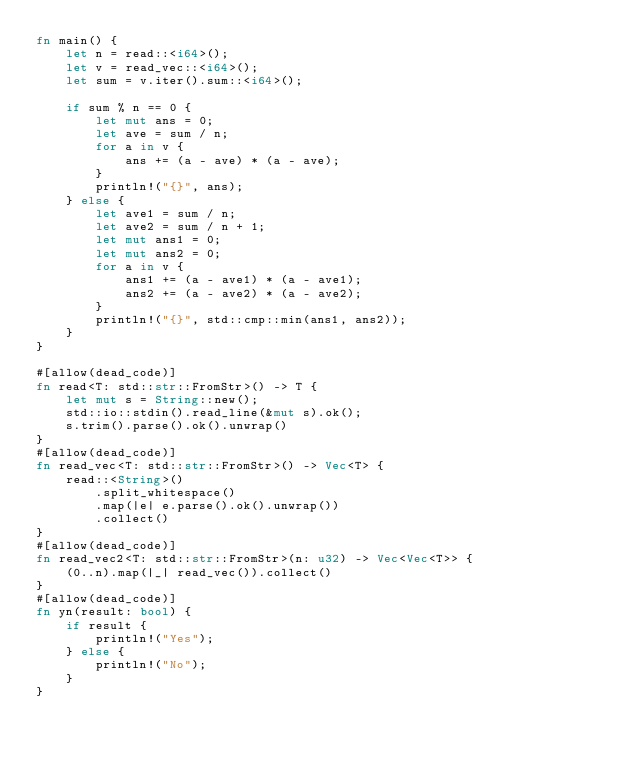<code> <loc_0><loc_0><loc_500><loc_500><_Rust_>fn main() {
    let n = read::<i64>();
    let v = read_vec::<i64>();
    let sum = v.iter().sum::<i64>();

    if sum % n == 0 {
        let mut ans = 0;
        let ave = sum / n;
        for a in v {
            ans += (a - ave) * (a - ave);
        }
        println!("{}", ans);
    } else {
        let ave1 = sum / n;
        let ave2 = sum / n + 1;
        let mut ans1 = 0;
        let mut ans2 = 0;
        for a in v {
            ans1 += (a - ave1) * (a - ave1);
            ans2 += (a - ave2) * (a - ave2);
        }
        println!("{}", std::cmp::min(ans1, ans2));
    }
}

#[allow(dead_code)]
fn read<T: std::str::FromStr>() -> T {
    let mut s = String::new();
    std::io::stdin().read_line(&mut s).ok();
    s.trim().parse().ok().unwrap()
}
#[allow(dead_code)]
fn read_vec<T: std::str::FromStr>() -> Vec<T> {
    read::<String>()
        .split_whitespace()
        .map(|e| e.parse().ok().unwrap())
        .collect()
}
#[allow(dead_code)]
fn read_vec2<T: std::str::FromStr>(n: u32) -> Vec<Vec<T>> {
    (0..n).map(|_| read_vec()).collect()
}
#[allow(dead_code)]
fn yn(result: bool) {
    if result {
        println!("Yes");
    } else {
        println!("No");
    }
}
</code> 